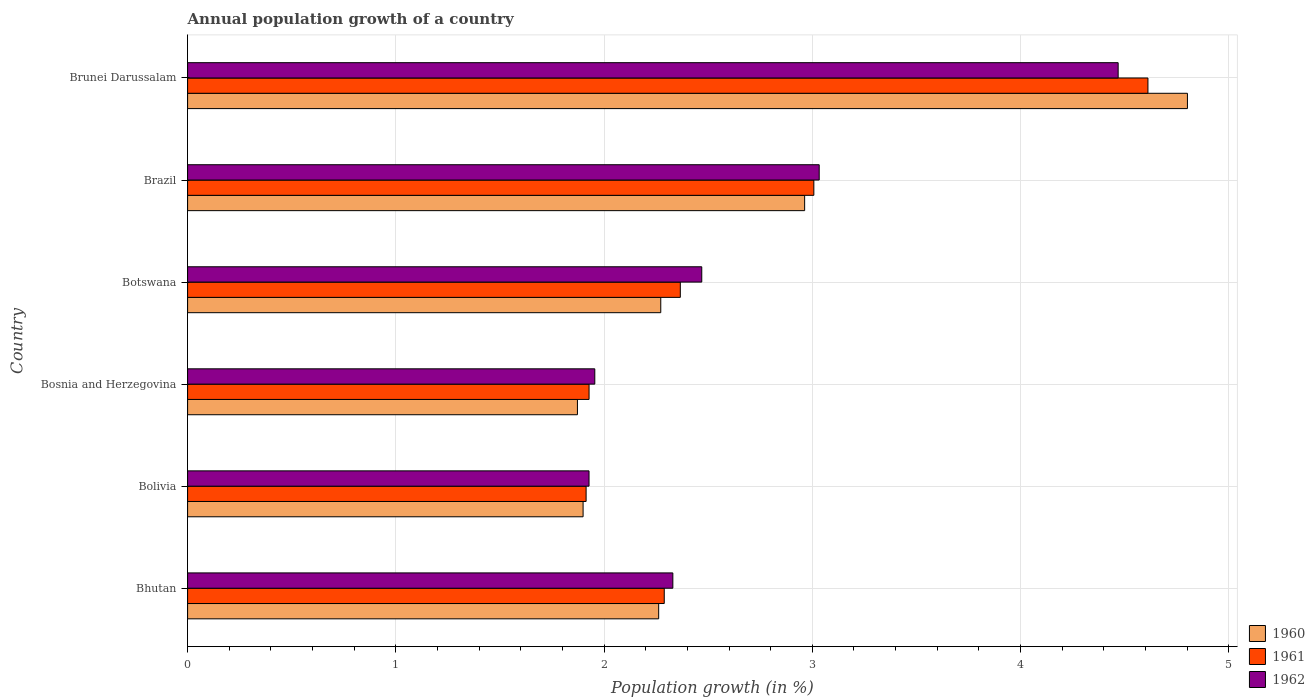How many different coloured bars are there?
Keep it short and to the point. 3. Are the number of bars per tick equal to the number of legend labels?
Give a very brief answer. Yes. Are the number of bars on each tick of the Y-axis equal?
Give a very brief answer. Yes. How many bars are there on the 4th tick from the top?
Keep it short and to the point. 3. How many bars are there on the 4th tick from the bottom?
Your answer should be compact. 3. What is the label of the 3rd group of bars from the top?
Give a very brief answer. Botswana. In how many cases, is the number of bars for a given country not equal to the number of legend labels?
Make the answer very short. 0. What is the annual population growth in 1961 in Botswana?
Offer a terse response. 2.37. Across all countries, what is the maximum annual population growth in 1961?
Provide a short and direct response. 4.61. Across all countries, what is the minimum annual population growth in 1961?
Your answer should be very brief. 1.91. In which country was the annual population growth in 1961 maximum?
Make the answer very short. Brunei Darussalam. In which country was the annual population growth in 1962 minimum?
Offer a terse response. Bolivia. What is the total annual population growth in 1961 in the graph?
Your response must be concise. 16.12. What is the difference between the annual population growth in 1961 in Bolivia and that in Brazil?
Your answer should be compact. -1.09. What is the difference between the annual population growth in 1960 in Bosnia and Herzegovina and the annual population growth in 1962 in Brazil?
Give a very brief answer. -1.16. What is the average annual population growth in 1960 per country?
Your response must be concise. 2.68. What is the difference between the annual population growth in 1960 and annual population growth in 1961 in Botswana?
Offer a terse response. -0.09. What is the ratio of the annual population growth in 1960 in Bolivia to that in Bosnia and Herzegovina?
Provide a short and direct response. 1.01. Is the annual population growth in 1962 in Bhutan less than that in Bosnia and Herzegovina?
Offer a terse response. No. Is the difference between the annual population growth in 1960 in Bolivia and Brunei Darussalam greater than the difference between the annual population growth in 1961 in Bolivia and Brunei Darussalam?
Give a very brief answer. No. What is the difference between the highest and the second highest annual population growth in 1961?
Offer a very short reply. 1.6. What is the difference between the highest and the lowest annual population growth in 1961?
Keep it short and to the point. 2.7. In how many countries, is the annual population growth in 1962 greater than the average annual population growth in 1962 taken over all countries?
Make the answer very short. 2. Is the sum of the annual population growth in 1960 in Bhutan and Bosnia and Herzegovina greater than the maximum annual population growth in 1961 across all countries?
Offer a terse response. No. What does the 1st bar from the top in Bhutan represents?
Give a very brief answer. 1962. What does the 2nd bar from the bottom in Bolivia represents?
Your response must be concise. 1961. How many bars are there?
Your response must be concise. 18. What is the difference between two consecutive major ticks on the X-axis?
Offer a very short reply. 1. Are the values on the major ticks of X-axis written in scientific E-notation?
Offer a very short reply. No. Does the graph contain grids?
Your response must be concise. Yes. What is the title of the graph?
Your response must be concise. Annual population growth of a country. Does "1969" appear as one of the legend labels in the graph?
Provide a short and direct response. No. What is the label or title of the X-axis?
Provide a short and direct response. Population growth (in %). What is the Population growth (in %) of 1960 in Bhutan?
Ensure brevity in your answer.  2.26. What is the Population growth (in %) in 1961 in Bhutan?
Keep it short and to the point. 2.29. What is the Population growth (in %) of 1962 in Bhutan?
Ensure brevity in your answer.  2.33. What is the Population growth (in %) in 1960 in Bolivia?
Give a very brief answer. 1.9. What is the Population growth (in %) of 1961 in Bolivia?
Keep it short and to the point. 1.91. What is the Population growth (in %) in 1962 in Bolivia?
Keep it short and to the point. 1.93. What is the Population growth (in %) in 1960 in Bosnia and Herzegovina?
Provide a short and direct response. 1.87. What is the Population growth (in %) in 1961 in Bosnia and Herzegovina?
Offer a terse response. 1.93. What is the Population growth (in %) in 1962 in Bosnia and Herzegovina?
Your response must be concise. 1.96. What is the Population growth (in %) in 1960 in Botswana?
Provide a succinct answer. 2.27. What is the Population growth (in %) in 1961 in Botswana?
Give a very brief answer. 2.37. What is the Population growth (in %) of 1962 in Botswana?
Your answer should be compact. 2.47. What is the Population growth (in %) of 1960 in Brazil?
Your response must be concise. 2.96. What is the Population growth (in %) in 1961 in Brazil?
Provide a short and direct response. 3.01. What is the Population growth (in %) in 1962 in Brazil?
Keep it short and to the point. 3.03. What is the Population growth (in %) of 1960 in Brunei Darussalam?
Make the answer very short. 4.8. What is the Population growth (in %) in 1961 in Brunei Darussalam?
Your answer should be very brief. 4.61. What is the Population growth (in %) in 1962 in Brunei Darussalam?
Your answer should be compact. 4.47. Across all countries, what is the maximum Population growth (in %) of 1960?
Your answer should be compact. 4.8. Across all countries, what is the maximum Population growth (in %) in 1961?
Offer a terse response. 4.61. Across all countries, what is the maximum Population growth (in %) of 1962?
Ensure brevity in your answer.  4.47. Across all countries, what is the minimum Population growth (in %) of 1960?
Your answer should be very brief. 1.87. Across all countries, what is the minimum Population growth (in %) of 1961?
Offer a very short reply. 1.91. Across all countries, what is the minimum Population growth (in %) of 1962?
Give a very brief answer. 1.93. What is the total Population growth (in %) of 1960 in the graph?
Offer a very short reply. 16.07. What is the total Population growth (in %) in 1961 in the graph?
Your answer should be compact. 16.12. What is the total Population growth (in %) in 1962 in the graph?
Keep it short and to the point. 16.18. What is the difference between the Population growth (in %) in 1960 in Bhutan and that in Bolivia?
Offer a terse response. 0.36. What is the difference between the Population growth (in %) in 1961 in Bhutan and that in Bolivia?
Provide a succinct answer. 0.38. What is the difference between the Population growth (in %) in 1962 in Bhutan and that in Bolivia?
Give a very brief answer. 0.4. What is the difference between the Population growth (in %) in 1960 in Bhutan and that in Bosnia and Herzegovina?
Your answer should be very brief. 0.39. What is the difference between the Population growth (in %) in 1961 in Bhutan and that in Bosnia and Herzegovina?
Offer a terse response. 0.36. What is the difference between the Population growth (in %) of 1962 in Bhutan and that in Bosnia and Herzegovina?
Provide a succinct answer. 0.37. What is the difference between the Population growth (in %) in 1960 in Bhutan and that in Botswana?
Offer a terse response. -0.01. What is the difference between the Population growth (in %) in 1961 in Bhutan and that in Botswana?
Offer a very short reply. -0.08. What is the difference between the Population growth (in %) of 1962 in Bhutan and that in Botswana?
Keep it short and to the point. -0.14. What is the difference between the Population growth (in %) in 1960 in Bhutan and that in Brazil?
Ensure brevity in your answer.  -0.7. What is the difference between the Population growth (in %) of 1961 in Bhutan and that in Brazil?
Ensure brevity in your answer.  -0.72. What is the difference between the Population growth (in %) of 1962 in Bhutan and that in Brazil?
Make the answer very short. -0.7. What is the difference between the Population growth (in %) of 1960 in Bhutan and that in Brunei Darussalam?
Your response must be concise. -2.54. What is the difference between the Population growth (in %) in 1961 in Bhutan and that in Brunei Darussalam?
Keep it short and to the point. -2.32. What is the difference between the Population growth (in %) of 1962 in Bhutan and that in Brunei Darussalam?
Provide a succinct answer. -2.14. What is the difference between the Population growth (in %) in 1960 in Bolivia and that in Bosnia and Herzegovina?
Offer a very short reply. 0.03. What is the difference between the Population growth (in %) in 1961 in Bolivia and that in Bosnia and Herzegovina?
Your response must be concise. -0.01. What is the difference between the Population growth (in %) in 1962 in Bolivia and that in Bosnia and Herzegovina?
Keep it short and to the point. -0.03. What is the difference between the Population growth (in %) in 1960 in Bolivia and that in Botswana?
Ensure brevity in your answer.  -0.37. What is the difference between the Population growth (in %) of 1961 in Bolivia and that in Botswana?
Make the answer very short. -0.45. What is the difference between the Population growth (in %) of 1962 in Bolivia and that in Botswana?
Provide a succinct answer. -0.54. What is the difference between the Population growth (in %) of 1960 in Bolivia and that in Brazil?
Provide a succinct answer. -1.06. What is the difference between the Population growth (in %) of 1961 in Bolivia and that in Brazil?
Offer a very short reply. -1.09. What is the difference between the Population growth (in %) in 1962 in Bolivia and that in Brazil?
Provide a succinct answer. -1.11. What is the difference between the Population growth (in %) of 1960 in Bolivia and that in Brunei Darussalam?
Offer a very short reply. -2.9. What is the difference between the Population growth (in %) in 1961 in Bolivia and that in Brunei Darussalam?
Provide a short and direct response. -2.7. What is the difference between the Population growth (in %) of 1962 in Bolivia and that in Brunei Darussalam?
Your answer should be compact. -2.54. What is the difference between the Population growth (in %) in 1960 in Bosnia and Herzegovina and that in Botswana?
Keep it short and to the point. -0.4. What is the difference between the Population growth (in %) of 1961 in Bosnia and Herzegovina and that in Botswana?
Keep it short and to the point. -0.44. What is the difference between the Population growth (in %) in 1962 in Bosnia and Herzegovina and that in Botswana?
Make the answer very short. -0.51. What is the difference between the Population growth (in %) in 1960 in Bosnia and Herzegovina and that in Brazil?
Make the answer very short. -1.09. What is the difference between the Population growth (in %) of 1961 in Bosnia and Herzegovina and that in Brazil?
Your response must be concise. -1.08. What is the difference between the Population growth (in %) in 1962 in Bosnia and Herzegovina and that in Brazil?
Ensure brevity in your answer.  -1.08. What is the difference between the Population growth (in %) in 1960 in Bosnia and Herzegovina and that in Brunei Darussalam?
Provide a succinct answer. -2.93. What is the difference between the Population growth (in %) of 1961 in Bosnia and Herzegovina and that in Brunei Darussalam?
Provide a succinct answer. -2.68. What is the difference between the Population growth (in %) in 1962 in Bosnia and Herzegovina and that in Brunei Darussalam?
Your answer should be compact. -2.51. What is the difference between the Population growth (in %) of 1960 in Botswana and that in Brazil?
Your answer should be compact. -0.69. What is the difference between the Population growth (in %) in 1961 in Botswana and that in Brazil?
Provide a succinct answer. -0.64. What is the difference between the Population growth (in %) in 1962 in Botswana and that in Brazil?
Offer a terse response. -0.56. What is the difference between the Population growth (in %) of 1960 in Botswana and that in Brunei Darussalam?
Offer a very short reply. -2.53. What is the difference between the Population growth (in %) in 1961 in Botswana and that in Brunei Darussalam?
Keep it short and to the point. -2.25. What is the difference between the Population growth (in %) of 1962 in Botswana and that in Brunei Darussalam?
Offer a terse response. -2. What is the difference between the Population growth (in %) in 1960 in Brazil and that in Brunei Darussalam?
Offer a very short reply. -1.84. What is the difference between the Population growth (in %) of 1961 in Brazil and that in Brunei Darussalam?
Your response must be concise. -1.6. What is the difference between the Population growth (in %) of 1962 in Brazil and that in Brunei Darussalam?
Your answer should be compact. -1.44. What is the difference between the Population growth (in %) in 1960 in Bhutan and the Population growth (in %) in 1961 in Bolivia?
Offer a terse response. 0.35. What is the difference between the Population growth (in %) of 1960 in Bhutan and the Population growth (in %) of 1962 in Bolivia?
Provide a short and direct response. 0.33. What is the difference between the Population growth (in %) in 1961 in Bhutan and the Population growth (in %) in 1962 in Bolivia?
Ensure brevity in your answer.  0.36. What is the difference between the Population growth (in %) of 1960 in Bhutan and the Population growth (in %) of 1961 in Bosnia and Herzegovina?
Offer a very short reply. 0.33. What is the difference between the Population growth (in %) of 1960 in Bhutan and the Population growth (in %) of 1962 in Bosnia and Herzegovina?
Make the answer very short. 0.31. What is the difference between the Population growth (in %) of 1961 in Bhutan and the Population growth (in %) of 1962 in Bosnia and Herzegovina?
Provide a succinct answer. 0.33. What is the difference between the Population growth (in %) in 1960 in Bhutan and the Population growth (in %) in 1961 in Botswana?
Provide a succinct answer. -0.1. What is the difference between the Population growth (in %) in 1960 in Bhutan and the Population growth (in %) in 1962 in Botswana?
Provide a short and direct response. -0.21. What is the difference between the Population growth (in %) in 1961 in Bhutan and the Population growth (in %) in 1962 in Botswana?
Give a very brief answer. -0.18. What is the difference between the Population growth (in %) in 1960 in Bhutan and the Population growth (in %) in 1961 in Brazil?
Provide a short and direct response. -0.75. What is the difference between the Population growth (in %) of 1960 in Bhutan and the Population growth (in %) of 1962 in Brazil?
Your answer should be compact. -0.77. What is the difference between the Population growth (in %) in 1961 in Bhutan and the Population growth (in %) in 1962 in Brazil?
Make the answer very short. -0.74. What is the difference between the Population growth (in %) of 1960 in Bhutan and the Population growth (in %) of 1961 in Brunei Darussalam?
Your answer should be very brief. -2.35. What is the difference between the Population growth (in %) in 1960 in Bhutan and the Population growth (in %) in 1962 in Brunei Darussalam?
Offer a terse response. -2.21. What is the difference between the Population growth (in %) of 1961 in Bhutan and the Population growth (in %) of 1962 in Brunei Darussalam?
Make the answer very short. -2.18. What is the difference between the Population growth (in %) of 1960 in Bolivia and the Population growth (in %) of 1961 in Bosnia and Herzegovina?
Keep it short and to the point. -0.03. What is the difference between the Population growth (in %) of 1960 in Bolivia and the Population growth (in %) of 1962 in Bosnia and Herzegovina?
Keep it short and to the point. -0.06. What is the difference between the Population growth (in %) of 1961 in Bolivia and the Population growth (in %) of 1962 in Bosnia and Herzegovina?
Your answer should be very brief. -0.04. What is the difference between the Population growth (in %) of 1960 in Bolivia and the Population growth (in %) of 1961 in Botswana?
Keep it short and to the point. -0.47. What is the difference between the Population growth (in %) in 1960 in Bolivia and the Population growth (in %) in 1962 in Botswana?
Make the answer very short. -0.57. What is the difference between the Population growth (in %) in 1961 in Bolivia and the Population growth (in %) in 1962 in Botswana?
Provide a short and direct response. -0.56. What is the difference between the Population growth (in %) in 1960 in Bolivia and the Population growth (in %) in 1961 in Brazil?
Ensure brevity in your answer.  -1.11. What is the difference between the Population growth (in %) of 1960 in Bolivia and the Population growth (in %) of 1962 in Brazil?
Keep it short and to the point. -1.13. What is the difference between the Population growth (in %) in 1961 in Bolivia and the Population growth (in %) in 1962 in Brazil?
Offer a very short reply. -1.12. What is the difference between the Population growth (in %) in 1960 in Bolivia and the Population growth (in %) in 1961 in Brunei Darussalam?
Provide a short and direct response. -2.71. What is the difference between the Population growth (in %) of 1960 in Bolivia and the Population growth (in %) of 1962 in Brunei Darussalam?
Give a very brief answer. -2.57. What is the difference between the Population growth (in %) in 1961 in Bolivia and the Population growth (in %) in 1962 in Brunei Darussalam?
Your answer should be very brief. -2.56. What is the difference between the Population growth (in %) in 1960 in Bosnia and Herzegovina and the Population growth (in %) in 1961 in Botswana?
Provide a short and direct response. -0.49. What is the difference between the Population growth (in %) in 1960 in Bosnia and Herzegovina and the Population growth (in %) in 1962 in Botswana?
Your answer should be very brief. -0.6. What is the difference between the Population growth (in %) in 1961 in Bosnia and Herzegovina and the Population growth (in %) in 1962 in Botswana?
Offer a terse response. -0.54. What is the difference between the Population growth (in %) in 1960 in Bosnia and Herzegovina and the Population growth (in %) in 1961 in Brazil?
Provide a short and direct response. -1.14. What is the difference between the Population growth (in %) in 1960 in Bosnia and Herzegovina and the Population growth (in %) in 1962 in Brazil?
Offer a terse response. -1.16. What is the difference between the Population growth (in %) in 1961 in Bosnia and Herzegovina and the Population growth (in %) in 1962 in Brazil?
Keep it short and to the point. -1.11. What is the difference between the Population growth (in %) of 1960 in Bosnia and Herzegovina and the Population growth (in %) of 1961 in Brunei Darussalam?
Provide a succinct answer. -2.74. What is the difference between the Population growth (in %) in 1960 in Bosnia and Herzegovina and the Population growth (in %) in 1962 in Brunei Darussalam?
Give a very brief answer. -2.6. What is the difference between the Population growth (in %) in 1961 in Bosnia and Herzegovina and the Population growth (in %) in 1962 in Brunei Darussalam?
Provide a succinct answer. -2.54. What is the difference between the Population growth (in %) in 1960 in Botswana and the Population growth (in %) in 1961 in Brazil?
Offer a very short reply. -0.74. What is the difference between the Population growth (in %) in 1960 in Botswana and the Population growth (in %) in 1962 in Brazil?
Your answer should be very brief. -0.76. What is the difference between the Population growth (in %) of 1961 in Botswana and the Population growth (in %) of 1962 in Brazil?
Your answer should be very brief. -0.67. What is the difference between the Population growth (in %) in 1960 in Botswana and the Population growth (in %) in 1961 in Brunei Darussalam?
Keep it short and to the point. -2.34. What is the difference between the Population growth (in %) of 1960 in Botswana and the Population growth (in %) of 1962 in Brunei Darussalam?
Your answer should be very brief. -2.2. What is the difference between the Population growth (in %) in 1961 in Botswana and the Population growth (in %) in 1962 in Brunei Darussalam?
Keep it short and to the point. -2.1. What is the difference between the Population growth (in %) in 1960 in Brazil and the Population growth (in %) in 1961 in Brunei Darussalam?
Offer a very short reply. -1.65. What is the difference between the Population growth (in %) of 1960 in Brazil and the Population growth (in %) of 1962 in Brunei Darussalam?
Provide a succinct answer. -1.51. What is the difference between the Population growth (in %) in 1961 in Brazil and the Population growth (in %) in 1962 in Brunei Darussalam?
Make the answer very short. -1.46. What is the average Population growth (in %) in 1960 per country?
Offer a terse response. 2.68. What is the average Population growth (in %) of 1961 per country?
Keep it short and to the point. 2.69. What is the average Population growth (in %) of 1962 per country?
Provide a succinct answer. 2.7. What is the difference between the Population growth (in %) in 1960 and Population growth (in %) in 1961 in Bhutan?
Your answer should be very brief. -0.03. What is the difference between the Population growth (in %) of 1960 and Population growth (in %) of 1962 in Bhutan?
Provide a succinct answer. -0.07. What is the difference between the Population growth (in %) in 1961 and Population growth (in %) in 1962 in Bhutan?
Keep it short and to the point. -0.04. What is the difference between the Population growth (in %) of 1960 and Population growth (in %) of 1961 in Bolivia?
Offer a terse response. -0.01. What is the difference between the Population growth (in %) in 1960 and Population growth (in %) in 1962 in Bolivia?
Keep it short and to the point. -0.03. What is the difference between the Population growth (in %) in 1961 and Population growth (in %) in 1962 in Bolivia?
Your response must be concise. -0.01. What is the difference between the Population growth (in %) in 1960 and Population growth (in %) in 1961 in Bosnia and Herzegovina?
Provide a succinct answer. -0.06. What is the difference between the Population growth (in %) in 1960 and Population growth (in %) in 1962 in Bosnia and Herzegovina?
Provide a short and direct response. -0.08. What is the difference between the Population growth (in %) in 1961 and Population growth (in %) in 1962 in Bosnia and Herzegovina?
Ensure brevity in your answer.  -0.03. What is the difference between the Population growth (in %) in 1960 and Population growth (in %) in 1961 in Botswana?
Keep it short and to the point. -0.09. What is the difference between the Population growth (in %) of 1960 and Population growth (in %) of 1962 in Botswana?
Keep it short and to the point. -0.2. What is the difference between the Population growth (in %) of 1961 and Population growth (in %) of 1962 in Botswana?
Provide a succinct answer. -0.1. What is the difference between the Population growth (in %) of 1960 and Population growth (in %) of 1961 in Brazil?
Offer a very short reply. -0.04. What is the difference between the Population growth (in %) of 1960 and Population growth (in %) of 1962 in Brazil?
Provide a short and direct response. -0.07. What is the difference between the Population growth (in %) in 1961 and Population growth (in %) in 1962 in Brazil?
Provide a short and direct response. -0.03. What is the difference between the Population growth (in %) of 1960 and Population growth (in %) of 1961 in Brunei Darussalam?
Your response must be concise. 0.19. What is the difference between the Population growth (in %) in 1960 and Population growth (in %) in 1962 in Brunei Darussalam?
Ensure brevity in your answer.  0.33. What is the difference between the Population growth (in %) of 1961 and Population growth (in %) of 1962 in Brunei Darussalam?
Keep it short and to the point. 0.14. What is the ratio of the Population growth (in %) in 1960 in Bhutan to that in Bolivia?
Provide a succinct answer. 1.19. What is the ratio of the Population growth (in %) in 1961 in Bhutan to that in Bolivia?
Keep it short and to the point. 1.2. What is the ratio of the Population growth (in %) in 1962 in Bhutan to that in Bolivia?
Give a very brief answer. 1.21. What is the ratio of the Population growth (in %) of 1960 in Bhutan to that in Bosnia and Herzegovina?
Your response must be concise. 1.21. What is the ratio of the Population growth (in %) in 1961 in Bhutan to that in Bosnia and Herzegovina?
Keep it short and to the point. 1.19. What is the ratio of the Population growth (in %) in 1962 in Bhutan to that in Bosnia and Herzegovina?
Provide a succinct answer. 1.19. What is the ratio of the Population growth (in %) in 1960 in Bhutan to that in Botswana?
Offer a very short reply. 1. What is the ratio of the Population growth (in %) of 1961 in Bhutan to that in Botswana?
Your answer should be very brief. 0.97. What is the ratio of the Population growth (in %) of 1962 in Bhutan to that in Botswana?
Your answer should be very brief. 0.94. What is the ratio of the Population growth (in %) in 1960 in Bhutan to that in Brazil?
Your answer should be very brief. 0.76. What is the ratio of the Population growth (in %) in 1961 in Bhutan to that in Brazil?
Ensure brevity in your answer.  0.76. What is the ratio of the Population growth (in %) in 1962 in Bhutan to that in Brazil?
Your response must be concise. 0.77. What is the ratio of the Population growth (in %) of 1960 in Bhutan to that in Brunei Darussalam?
Ensure brevity in your answer.  0.47. What is the ratio of the Population growth (in %) in 1961 in Bhutan to that in Brunei Darussalam?
Make the answer very short. 0.5. What is the ratio of the Population growth (in %) of 1962 in Bhutan to that in Brunei Darussalam?
Your answer should be very brief. 0.52. What is the ratio of the Population growth (in %) in 1960 in Bolivia to that in Bosnia and Herzegovina?
Offer a terse response. 1.01. What is the ratio of the Population growth (in %) of 1962 in Bolivia to that in Bosnia and Herzegovina?
Your answer should be very brief. 0.99. What is the ratio of the Population growth (in %) in 1960 in Bolivia to that in Botswana?
Provide a succinct answer. 0.84. What is the ratio of the Population growth (in %) in 1961 in Bolivia to that in Botswana?
Make the answer very short. 0.81. What is the ratio of the Population growth (in %) in 1962 in Bolivia to that in Botswana?
Offer a very short reply. 0.78. What is the ratio of the Population growth (in %) of 1960 in Bolivia to that in Brazil?
Offer a very short reply. 0.64. What is the ratio of the Population growth (in %) in 1961 in Bolivia to that in Brazil?
Your answer should be compact. 0.64. What is the ratio of the Population growth (in %) of 1962 in Bolivia to that in Brazil?
Offer a terse response. 0.64. What is the ratio of the Population growth (in %) of 1960 in Bolivia to that in Brunei Darussalam?
Offer a very short reply. 0.4. What is the ratio of the Population growth (in %) of 1961 in Bolivia to that in Brunei Darussalam?
Provide a succinct answer. 0.41. What is the ratio of the Population growth (in %) of 1962 in Bolivia to that in Brunei Darussalam?
Your answer should be compact. 0.43. What is the ratio of the Population growth (in %) of 1960 in Bosnia and Herzegovina to that in Botswana?
Offer a very short reply. 0.82. What is the ratio of the Population growth (in %) in 1961 in Bosnia and Herzegovina to that in Botswana?
Your answer should be compact. 0.81. What is the ratio of the Population growth (in %) in 1962 in Bosnia and Herzegovina to that in Botswana?
Keep it short and to the point. 0.79. What is the ratio of the Population growth (in %) of 1960 in Bosnia and Herzegovina to that in Brazil?
Make the answer very short. 0.63. What is the ratio of the Population growth (in %) in 1961 in Bosnia and Herzegovina to that in Brazil?
Your answer should be very brief. 0.64. What is the ratio of the Population growth (in %) in 1962 in Bosnia and Herzegovina to that in Brazil?
Ensure brevity in your answer.  0.64. What is the ratio of the Population growth (in %) of 1960 in Bosnia and Herzegovina to that in Brunei Darussalam?
Your response must be concise. 0.39. What is the ratio of the Population growth (in %) in 1961 in Bosnia and Herzegovina to that in Brunei Darussalam?
Your answer should be compact. 0.42. What is the ratio of the Population growth (in %) in 1962 in Bosnia and Herzegovina to that in Brunei Darussalam?
Your response must be concise. 0.44. What is the ratio of the Population growth (in %) of 1960 in Botswana to that in Brazil?
Your answer should be compact. 0.77. What is the ratio of the Population growth (in %) in 1961 in Botswana to that in Brazil?
Offer a very short reply. 0.79. What is the ratio of the Population growth (in %) in 1962 in Botswana to that in Brazil?
Offer a terse response. 0.81. What is the ratio of the Population growth (in %) in 1960 in Botswana to that in Brunei Darussalam?
Make the answer very short. 0.47. What is the ratio of the Population growth (in %) of 1961 in Botswana to that in Brunei Darussalam?
Give a very brief answer. 0.51. What is the ratio of the Population growth (in %) in 1962 in Botswana to that in Brunei Darussalam?
Your answer should be very brief. 0.55. What is the ratio of the Population growth (in %) of 1960 in Brazil to that in Brunei Darussalam?
Your answer should be very brief. 0.62. What is the ratio of the Population growth (in %) of 1961 in Brazil to that in Brunei Darussalam?
Ensure brevity in your answer.  0.65. What is the ratio of the Population growth (in %) of 1962 in Brazil to that in Brunei Darussalam?
Offer a very short reply. 0.68. What is the difference between the highest and the second highest Population growth (in %) of 1960?
Make the answer very short. 1.84. What is the difference between the highest and the second highest Population growth (in %) of 1961?
Give a very brief answer. 1.6. What is the difference between the highest and the second highest Population growth (in %) in 1962?
Make the answer very short. 1.44. What is the difference between the highest and the lowest Population growth (in %) of 1960?
Your response must be concise. 2.93. What is the difference between the highest and the lowest Population growth (in %) of 1961?
Keep it short and to the point. 2.7. What is the difference between the highest and the lowest Population growth (in %) in 1962?
Your answer should be very brief. 2.54. 